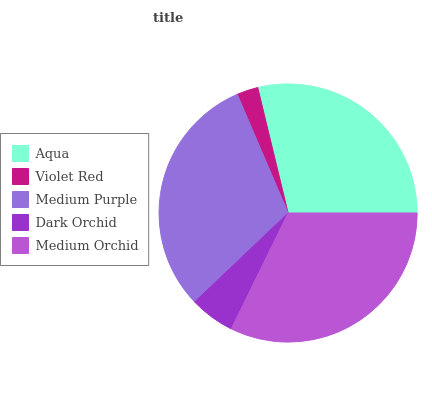Is Violet Red the minimum?
Answer yes or no. Yes. Is Medium Orchid the maximum?
Answer yes or no. Yes. Is Medium Purple the minimum?
Answer yes or no. No. Is Medium Purple the maximum?
Answer yes or no. No. Is Medium Purple greater than Violet Red?
Answer yes or no. Yes. Is Violet Red less than Medium Purple?
Answer yes or no. Yes. Is Violet Red greater than Medium Purple?
Answer yes or no. No. Is Medium Purple less than Violet Red?
Answer yes or no. No. Is Aqua the high median?
Answer yes or no. Yes. Is Aqua the low median?
Answer yes or no. Yes. Is Dark Orchid the high median?
Answer yes or no. No. Is Dark Orchid the low median?
Answer yes or no. No. 